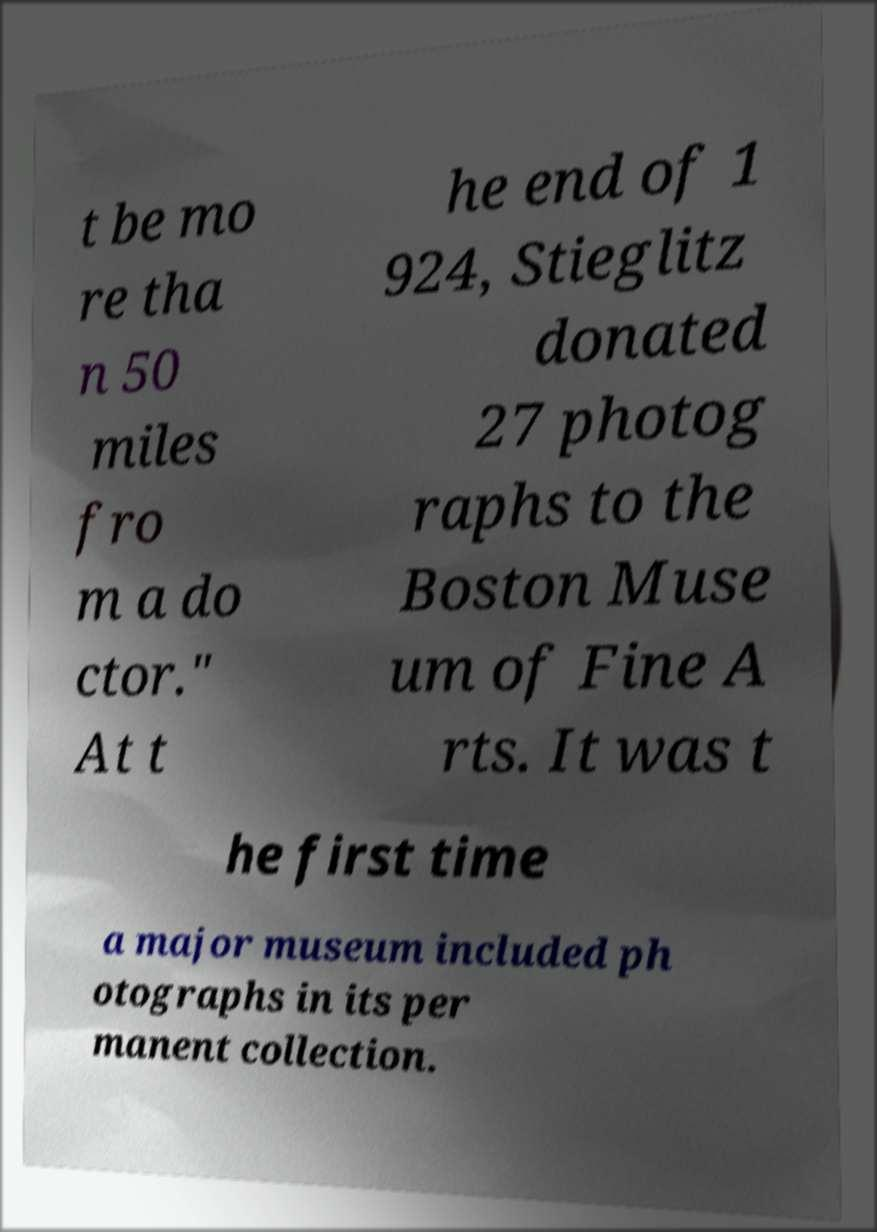For documentation purposes, I need the text within this image transcribed. Could you provide that? t be mo re tha n 50 miles fro m a do ctor." At t he end of 1 924, Stieglitz donated 27 photog raphs to the Boston Muse um of Fine A rts. It was t he first time a major museum included ph otographs in its per manent collection. 